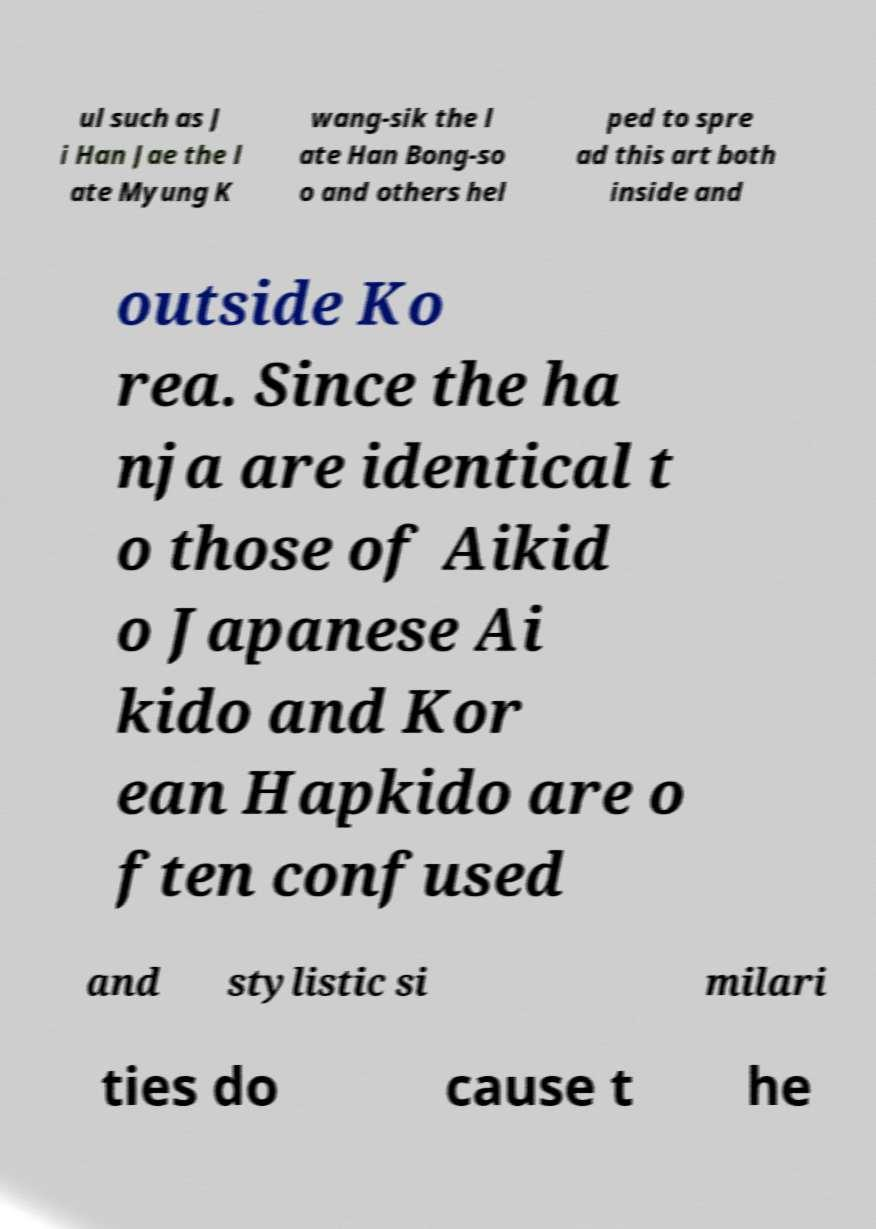There's text embedded in this image that I need extracted. Can you transcribe it verbatim? ul such as J i Han Jae the l ate Myung K wang-sik the l ate Han Bong-so o and others hel ped to spre ad this art both inside and outside Ko rea. Since the ha nja are identical t o those of Aikid o Japanese Ai kido and Kor ean Hapkido are o ften confused and stylistic si milari ties do cause t he 